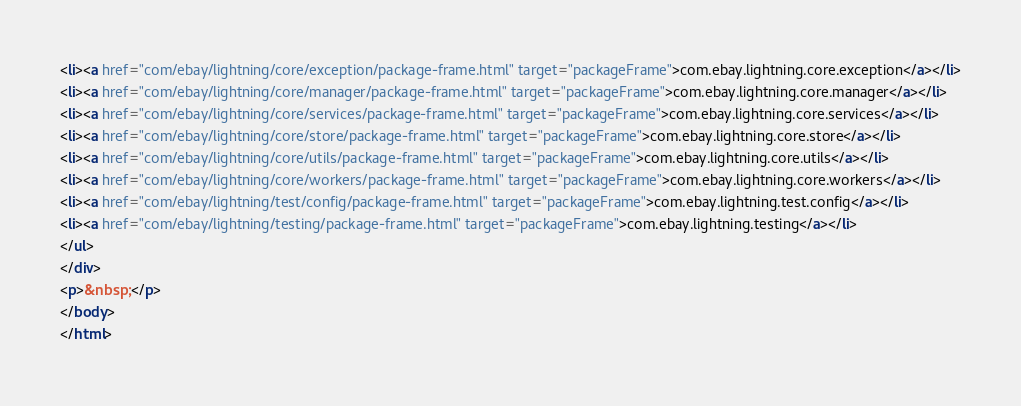Convert code to text. <code><loc_0><loc_0><loc_500><loc_500><_HTML_><li><a href="com/ebay/lightning/core/exception/package-frame.html" target="packageFrame">com.ebay.lightning.core.exception</a></li>
<li><a href="com/ebay/lightning/core/manager/package-frame.html" target="packageFrame">com.ebay.lightning.core.manager</a></li>
<li><a href="com/ebay/lightning/core/services/package-frame.html" target="packageFrame">com.ebay.lightning.core.services</a></li>
<li><a href="com/ebay/lightning/core/store/package-frame.html" target="packageFrame">com.ebay.lightning.core.store</a></li>
<li><a href="com/ebay/lightning/core/utils/package-frame.html" target="packageFrame">com.ebay.lightning.core.utils</a></li>
<li><a href="com/ebay/lightning/core/workers/package-frame.html" target="packageFrame">com.ebay.lightning.core.workers</a></li>
<li><a href="com/ebay/lightning/test/config/package-frame.html" target="packageFrame">com.ebay.lightning.test.config</a></li>
<li><a href="com/ebay/lightning/testing/package-frame.html" target="packageFrame">com.ebay.lightning.testing</a></li>
</ul>
</div>
<p>&nbsp;</p>
</body>
</html>
</code> 